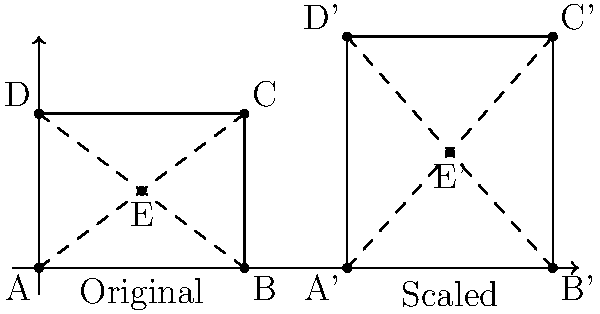In post-production, you need to scale a CGI character's proportions. The original character is represented by the rectangle ABCD with a central point E. The character needs to be scaled uniformly by a factor of 1.5. If the original rectangle has dimensions 4 units by 3 units, what will be the distance between points E' and C' in the scaled version? Let's approach this step-by-step:

1) In the original rectangle:
   - Width = 4 units
   - Height = 3 units
   - E is at the center (2, 1.5)

2) After scaling by a factor of 1.5:
   - New width = 4 * 1.5 = 6 units
   - New height = 3 * 1.5 = 4.5 units
   - E' will be at (3, 2.25)

3) In the scaled version, C' will be at (6, 4.5)

4) To find the distance between E' and C', we can use the distance formula:
   $$d = \sqrt{(x_2-x_1)^2 + (y_2-y_1)^2}$$

5) Plugging in the coordinates:
   $$d = \sqrt{(6-3)^2 + (4.5-2.25)^2}$$

6) Simplifying:
   $$d = \sqrt{3^2 + 2.25^2} = \sqrt{9 + 5.0625} = \sqrt{14.0625}$$

7) Calculating the square root:
   $$d = 3.75$$

Therefore, the distance between E' and C' in the scaled version is 3.75 units.
Answer: 3.75 units 